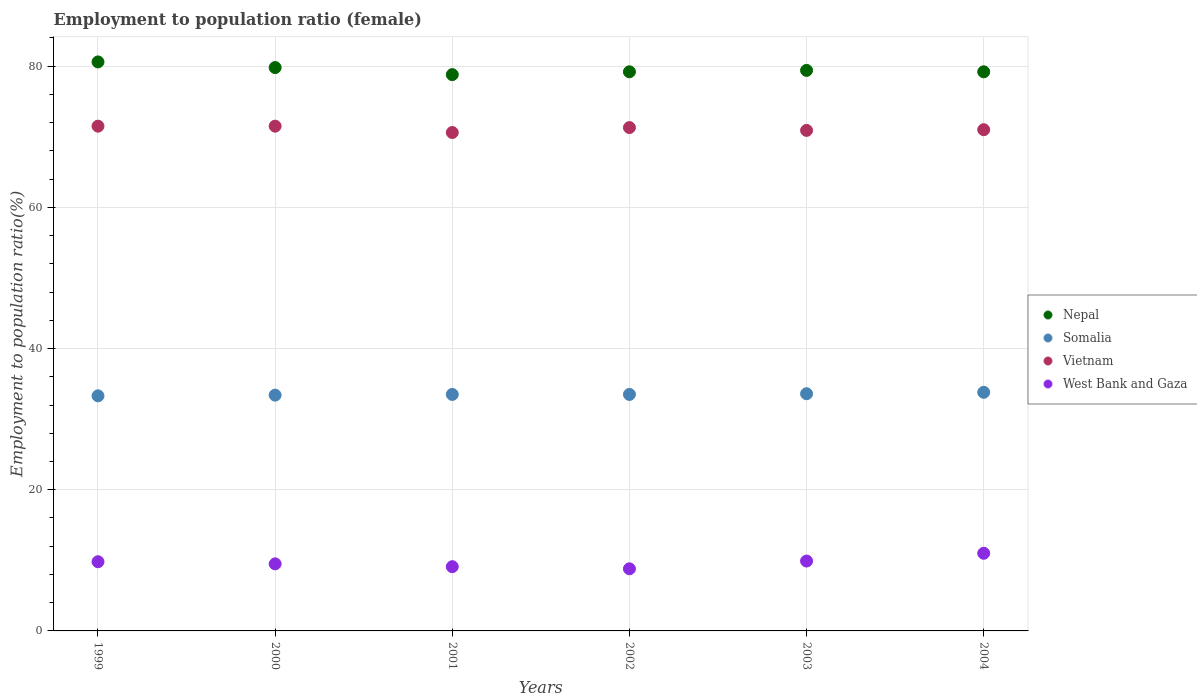How many different coloured dotlines are there?
Make the answer very short. 4. Is the number of dotlines equal to the number of legend labels?
Your answer should be very brief. Yes. What is the employment to population ratio in West Bank and Gaza in 2003?
Offer a terse response. 9.9. Across all years, what is the maximum employment to population ratio in Somalia?
Ensure brevity in your answer.  33.8. Across all years, what is the minimum employment to population ratio in West Bank and Gaza?
Provide a short and direct response. 8.8. In which year was the employment to population ratio in Vietnam maximum?
Provide a succinct answer. 1999. In which year was the employment to population ratio in Vietnam minimum?
Make the answer very short. 2001. What is the total employment to population ratio in Somalia in the graph?
Give a very brief answer. 201.1. What is the difference between the employment to population ratio in Nepal in 2000 and that in 2002?
Provide a succinct answer. 0.6. What is the difference between the employment to population ratio in Nepal in 2003 and the employment to population ratio in Vietnam in 2001?
Ensure brevity in your answer.  8.8. What is the average employment to population ratio in Somalia per year?
Your answer should be very brief. 33.52. In the year 2004, what is the difference between the employment to population ratio in Somalia and employment to population ratio in Nepal?
Your answer should be compact. -45.4. In how many years, is the employment to population ratio in Somalia greater than 4 %?
Provide a succinct answer. 6. What is the ratio of the employment to population ratio in West Bank and Gaza in 1999 to that in 2001?
Ensure brevity in your answer.  1.08. Is the employment to population ratio in Somalia in 2000 less than that in 2003?
Offer a very short reply. Yes. What is the difference between the highest and the second highest employment to population ratio in Vietnam?
Your response must be concise. 0. What is the difference between the highest and the lowest employment to population ratio in West Bank and Gaza?
Offer a very short reply. 2.2. Is the sum of the employment to population ratio in Nepal in 1999 and 2001 greater than the maximum employment to population ratio in West Bank and Gaza across all years?
Provide a short and direct response. Yes. Is it the case that in every year, the sum of the employment to population ratio in Vietnam and employment to population ratio in West Bank and Gaza  is greater than the employment to population ratio in Nepal?
Provide a short and direct response. Yes. Is the employment to population ratio in Vietnam strictly greater than the employment to population ratio in Somalia over the years?
Keep it short and to the point. Yes. Is the employment to population ratio in West Bank and Gaza strictly less than the employment to population ratio in Somalia over the years?
Keep it short and to the point. Yes. How many dotlines are there?
Provide a succinct answer. 4. How many years are there in the graph?
Your response must be concise. 6. Does the graph contain grids?
Offer a terse response. Yes. Where does the legend appear in the graph?
Provide a short and direct response. Center right. How many legend labels are there?
Make the answer very short. 4. What is the title of the graph?
Keep it short and to the point. Employment to population ratio (female). Does "Congo (Republic)" appear as one of the legend labels in the graph?
Provide a short and direct response. No. What is the label or title of the X-axis?
Make the answer very short. Years. What is the Employment to population ratio(%) in Nepal in 1999?
Make the answer very short. 80.6. What is the Employment to population ratio(%) in Somalia in 1999?
Your answer should be compact. 33.3. What is the Employment to population ratio(%) of Vietnam in 1999?
Your answer should be very brief. 71.5. What is the Employment to population ratio(%) of West Bank and Gaza in 1999?
Your answer should be very brief. 9.8. What is the Employment to population ratio(%) in Nepal in 2000?
Offer a very short reply. 79.8. What is the Employment to population ratio(%) of Somalia in 2000?
Provide a short and direct response. 33.4. What is the Employment to population ratio(%) in Vietnam in 2000?
Give a very brief answer. 71.5. What is the Employment to population ratio(%) in West Bank and Gaza in 2000?
Provide a short and direct response. 9.5. What is the Employment to population ratio(%) of Nepal in 2001?
Make the answer very short. 78.8. What is the Employment to population ratio(%) in Somalia in 2001?
Provide a short and direct response. 33.5. What is the Employment to population ratio(%) of Vietnam in 2001?
Your answer should be compact. 70.6. What is the Employment to population ratio(%) of West Bank and Gaza in 2001?
Your answer should be very brief. 9.1. What is the Employment to population ratio(%) in Nepal in 2002?
Your answer should be compact. 79.2. What is the Employment to population ratio(%) in Somalia in 2002?
Keep it short and to the point. 33.5. What is the Employment to population ratio(%) of Vietnam in 2002?
Ensure brevity in your answer.  71.3. What is the Employment to population ratio(%) of West Bank and Gaza in 2002?
Offer a terse response. 8.8. What is the Employment to population ratio(%) in Nepal in 2003?
Offer a terse response. 79.4. What is the Employment to population ratio(%) in Somalia in 2003?
Offer a very short reply. 33.6. What is the Employment to population ratio(%) in Vietnam in 2003?
Give a very brief answer. 70.9. What is the Employment to population ratio(%) in West Bank and Gaza in 2003?
Make the answer very short. 9.9. What is the Employment to population ratio(%) in Nepal in 2004?
Make the answer very short. 79.2. What is the Employment to population ratio(%) in Somalia in 2004?
Make the answer very short. 33.8. What is the Employment to population ratio(%) of West Bank and Gaza in 2004?
Your answer should be very brief. 11. Across all years, what is the maximum Employment to population ratio(%) of Nepal?
Give a very brief answer. 80.6. Across all years, what is the maximum Employment to population ratio(%) in Somalia?
Keep it short and to the point. 33.8. Across all years, what is the maximum Employment to population ratio(%) of Vietnam?
Provide a succinct answer. 71.5. Across all years, what is the minimum Employment to population ratio(%) of Nepal?
Ensure brevity in your answer.  78.8. Across all years, what is the minimum Employment to population ratio(%) of Somalia?
Your response must be concise. 33.3. Across all years, what is the minimum Employment to population ratio(%) of Vietnam?
Your answer should be compact. 70.6. Across all years, what is the minimum Employment to population ratio(%) of West Bank and Gaza?
Provide a succinct answer. 8.8. What is the total Employment to population ratio(%) in Nepal in the graph?
Your response must be concise. 477. What is the total Employment to population ratio(%) in Somalia in the graph?
Your answer should be very brief. 201.1. What is the total Employment to population ratio(%) of Vietnam in the graph?
Your answer should be very brief. 426.8. What is the total Employment to population ratio(%) of West Bank and Gaza in the graph?
Your answer should be very brief. 58.1. What is the difference between the Employment to population ratio(%) in Nepal in 1999 and that in 2000?
Give a very brief answer. 0.8. What is the difference between the Employment to population ratio(%) in Somalia in 1999 and that in 2000?
Offer a very short reply. -0.1. What is the difference between the Employment to population ratio(%) of West Bank and Gaza in 1999 and that in 2000?
Your response must be concise. 0.3. What is the difference between the Employment to population ratio(%) of Vietnam in 1999 and that in 2001?
Ensure brevity in your answer.  0.9. What is the difference between the Employment to population ratio(%) of West Bank and Gaza in 1999 and that in 2001?
Keep it short and to the point. 0.7. What is the difference between the Employment to population ratio(%) in Somalia in 1999 and that in 2002?
Make the answer very short. -0.2. What is the difference between the Employment to population ratio(%) in Vietnam in 1999 and that in 2002?
Offer a terse response. 0.2. What is the difference between the Employment to population ratio(%) of Nepal in 1999 and that in 2003?
Offer a very short reply. 1.2. What is the difference between the Employment to population ratio(%) in Vietnam in 1999 and that in 2004?
Offer a very short reply. 0.5. What is the difference between the Employment to population ratio(%) in West Bank and Gaza in 1999 and that in 2004?
Make the answer very short. -1.2. What is the difference between the Employment to population ratio(%) of Nepal in 2000 and that in 2001?
Provide a succinct answer. 1. What is the difference between the Employment to population ratio(%) in Vietnam in 2000 and that in 2001?
Ensure brevity in your answer.  0.9. What is the difference between the Employment to population ratio(%) of West Bank and Gaza in 2000 and that in 2001?
Provide a succinct answer. 0.4. What is the difference between the Employment to population ratio(%) in Nepal in 2000 and that in 2002?
Your response must be concise. 0.6. What is the difference between the Employment to population ratio(%) in Somalia in 2000 and that in 2002?
Provide a short and direct response. -0.1. What is the difference between the Employment to population ratio(%) of Somalia in 2000 and that in 2003?
Ensure brevity in your answer.  -0.2. What is the difference between the Employment to population ratio(%) in Vietnam in 2000 and that in 2003?
Ensure brevity in your answer.  0.6. What is the difference between the Employment to population ratio(%) in West Bank and Gaza in 2000 and that in 2003?
Offer a terse response. -0.4. What is the difference between the Employment to population ratio(%) in Somalia in 2000 and that in 2004?
Ensure brevity in your answer.  -0.4. What is the difference between the Employment to population ratio(%) in Vietnam in 2000 and that in 2004?
Give a very brief answer. 0.5. What is the difference between the Employment to population ratio(%) of Nepal in 2001 and that in 2002?
Ensure brevity in your answer.  -0.4. What is the difference between the Employment to population ratio(%) in West Bank and Gaza in 2001 and that in 2002?
Give a very brief answer. 0.3. What is the difference between the Employment to population ratio(%) in Vietnam in 2001 and that in 2003?
Your answer should be compact. -0.3. What is the difference between the Employment to population ratio(%) of Nepal in 2001 and that in 2004?
Offer a very short reply. -0.4. What is the difference between the Employment to population ratio(%) of Vietnam in 2001 and that in 2004?
Offer a terse response. -0.4. What is the difference between the Employment to population ratio(%) of West Bank and Gaza in 2001 and that in 2004?
Ensure brevity in your answer.  -1.9. What is the difference between the Employment to population ratio(%) in Vietnam in 2002 and that in 2003?
Your response must be concise. 0.4. What is the difference between the Employment to population ratio(%) in West Bank and Gaza in 2002 and that in 2003?
Your answer should be very brief. -1.1. What is the difference between the Employment to population ratio(%) of Nepal in 2002 and that in 2004?
Provide a succinct answer. 0. What is the difference between the Employment to population ratio(%) of West Bank and Gaza in 2002 and that in 2004?
Keep it short and to the point. -2.2. What is the difference between the Employment to population ratio(%) in Nepal in 2003 and that in 2004?
Your response must be concise. 0.2. What is the difference between the Employment to population ratio(%) in Somalia in 2003 and that in 2004?
Offer a terse response. -0.2. What is the difference between the Employment to population ratio(%) in Nepal in 1999 and the Employment to population ratio(%) in Somalia in 2000?
Offer a very short reply. 47.2. What is the difference between the Employment to population ratio(%) of Nepal in 1999 and the Employment to population ratio(%) of Vietnam in 2000?
Give a very brief answer. 9.1. What is the difference between the Employment to population ratio(%) in Nepal in 1999 and the Employment to population ratio(%) in West Bank and Gaza in 2000?
Make the answer very short. 71.1. What is the difference between the Employment to population ratio(%) of Somalia in 1999 and the Employment to population ratio(%) of Vietnam in 2000?
Your answer should be very brief. -38.2. What is the difference between the Employment to population ratio(%) in Somalia in 1999 and the Employment to population ratio(%) in West Bank and Gaza in 2000?
Provide a succinct answer. 23.8. What is the difference between the Employment to population ratio(%) in Vietnam in 1999 and the Employment to population ratio(%) in West Bank and Gaza in 2000?
Provide a succinct answer. 62. What is the difference between the Employment to population ratio(%) of Nepal in 1999 and the Employment to population ratio(%) of Somalia in 2001?
Provide a succinct answer. 47.1. What is the difference between the Employment to population ratio(%) of Nepal in 1999 and the Employment to population ratio(%) of Vietnam in 2001?
Give a very brief answer. 10. What is the difference between the Employment to population ratio(%) in Nepal in 1999 and the Employment to population ratio(%) in West Bank and Gaza in 2001?
Your response must be concise. 71.5. What is the difference between the Employment to population ratio(%) of Somalia in 1999 and the Employment to population ratio(%) of Vietnam in 2001?
Give a very brief answer. -37.3. What is the difference between the Employment to population ratio(%) of Somalia in 1999 and the Employment to population ratio(%) of West Bank and Gaza in 2001?
Provide a succinct answer. 24.2. What is the difference between the Employment to population ratio(%) of Vietnam in 1999 and the Employment to population ratio(%) of West Bank and Gaza in 2001?
Make the answer very short. 62.4. What is the difference between the Employment to population ratio(%) of Nepal in 1999 and the Employment to population ratio(%) of Somalia in 2002?
Offer a very short reply. 47.1. What is the difference between the Employment to population ratio(%) of Nepal in 1999 and the Employment to population ratio(%) of Vietnam in 2002?
Give a very brief answer. 9.3. What is the difference between the Employment to population ratio(%) in Nepal in 1999 and the Employment to population ratio(%) in West Bank and Gaza in 2002?
Your response must be concise. 71.8. What is the difference between the Employment to population ratio(%) of Somalia in 1999 and the Employment to population ratio(%) of Vietnam in 2002?
Keep it short and to the point. -38. What is the difference between the Employment to population ratio(%) of Somalia in 1999 and the Employment to population ratio(%) of West Bank and Gaza in 2002?
Make the answer very short. 24.5. What is the difference between the Employment to population ratio(%) in Vietnam in 1999 and the Employment to population ratio(%) in West Bank and Gaza in 2002?
Offer a terse response. 62.7. What is the difference between the Employment to population ratio(%) of Nepal in 1999 and the Employment to population ratio(%) of Somalia in 2003?
Make the answer very short. 47. What is the difference between the Employment to population ratio(%) in Nepal in 1999 and the Employment to population ratio(%) in West Bank and Gaza in 2003?
Make the answer very short. 70.7. What is the difference between the Employment to population ratio(%) of Somalia in 1999 and the Employment to population ratio(%) of Vietnam in 2003?
Your response must be concise. -37.6. What is the difference between the Employment to population ratio(%) in Somalia in 1999 and the Employment to population ratio(%) in West Bank and Gaza in 2003?
Offer a terse response. 23.4. What is the difference between the Employment to population ratio(%) of Vietnam in 1999 and the Employment to population ratio(%) of West Bank and Gaza in 2003?
Ensure brevity in your answer.  61.6. What is the difference between the Employment to population ratio(%) in Nepal in 1999 and the Employment to population ratio(%) in Somalia in 2004?
Your answer should be compact. 46.8. What is the difference between the Employment to population ratio(%) of Nepal in 1999 and the Employment to population ratio(%) of Vietnam in 2004?
Keep it short and to the point. 9.6. What is the difference between the Employment to population ratio(%) in Nepal in 1999 and the Employment to population ratio(%) in West Bank and Gaza in 2004?
Offer a very short reply. 69.6. What is the difference between the Employment to population ratio(%) of Somalia in 1999 and the Employment to population ratio(%) of Vietnam in 2004?
Offer a terse response. -37.7. What is the difference between the Employment to population ratio(%) of Somalia in 1999 and the Employment to population ratio(%) of West Bank and Gaza in 2004?
Give a very brief answer. 22.3. What is the difference between the Employment to population ratio(%) in Vietnam in 1999 and the Employment to population ratio(%) in West Bank and Gaza in 2004?
Keep it short and to the point. 60.5. What is the difference between the Employment to population ratio(%) of Nepal in 2000 and the Employment to population ratio(%) of Somalia in 2001?
Give a very brief answer. 46.3. What is the difference between the Employment to population ratio(%) of Nepal in 2000 and the Employment to population ratio(%) of West Bank and Gaza in 2001?
Provide a succinct answer. 70.7. What is the difference between the Employment to population ratio(%) in Somalia in 2000 and the Employment to population ratio(%) in Vietnam in 2001?
Ensure brevity in your answer.  -37.2. What is the difference between the Employment to population ratio(%) in Somalia in 2000 and the Employment to population ratio(%) in West Bank and Gaza in 2001?
Provide a short and direct response. 24.3. What is the difference between the Employment to population ratio(%) in Vietnam in 2000 and the Employment to population ratio(%) in West Bank and Gaza in 2001?
Offer a very short reply. 62.4. What is the difference between the Employment to population ratio(%) of Nepal in 2000 and the Employment to population ratio(%) of Somalia in 2002?
Offer a very short reply. 46.3. What is the difference between the Employment to population ratio(%) of Nepal in 2000 and the Employment to population ratio(%) of Vietnam in 2002?
Offer a terse response. 8.5. What is the difference between the Employment to population ratio(%) in Nepal in 2000 and the Employment to population ratio(%) in West Bank and Gaza in 2002?
Provide a short and direct response. 71. What is the difference between the Employment to population ratio(%) of Somalia in 2000 and the Employment to population ratio(%) of Vietnam in 2002?
Provide a succinct answer. -37.9. What is the difference between the Employment to population ratio(%) of Somalia in 2000 and the Employment to population ratio(%) of West Bank and Gaza in 2002?
Make the answer very short. 24.6. What is the difference between the Employment to population ratio(%) of Vietnam in 2000 and the Employment to population ratio(%) of West Bank and Gaza in 2002?
Offer a terse response. 62.7. What is the difference between the Employment to population ratio(%) of Nepal in 2000 and the Employment to population ratio(%) of Somalia in 2003?
Keep it short and to the point. 46.2. What is the difference between the Employment to population ratio(%) of Nepal in 2000 and the Employment to population ratio(%) of West Bank and Gaza in 2003?
Your answer should be compact. 69.9. What is the difference between the Employment to population ratio(%) of Somalia in 2000 and the Employment to population ratio(%) of Vietnam in 2003?
Give a very brief answer. -37.5. What is the difference between the Employment to population ratio(%) in Vietnam in 2000 and the Employment to population ratio(%) in West Bank and Gaza in 2003?
Your response must be concise. 61.6. What is the difference between the Employment to population ratio(%) in Nepal in 2000 and the Employment to population ratio(%) in Somalia in 2004?
Offer a terse response. 46. What is the difference between the Employment to population ratio(%) in Nepal in 2000 and the Employment to population ratio(%) in Vietnam in 2004?
Provide a short and direct response. 8.8. What is the difference between the Employment to population ratio(%) of Nepal in 2000 and the Employment to population ratio(%) of West Bank and Gaza in 2004?
Make the answer very short. 68.8. What is the difference between the Employment to population ratio(%) of Somalia in 2000 and the Employment to population ratio(%) of Vietnam in 2004?
Offer a terse response. -37.6. What is the difference between the Employment to population ratio(%) of Somalia in 2000 and the Employment to population ratio(%) of West Bank and Gaza in 2004?
Keep it short and to the point. 22.4. What is the difference between the Employment to population ratio(%) in Vietnam in 2000 and the Employment to population ratio(%) in West Bank and Gaza in 2004?
Provide a succinct answer. 60.5. What is the difference between the Employment to population ratio(%) of Nepal in 2001 and the Employment to population ratio(%) of Somalia in 2002?
Your answer should be compact. 45.3. What is the difference between the Employment to population ratio(%) in Somalia in 2001 and the Employment to population ratio(%) in Vietnam in 2002?
Ensure brevity in your answer.  -37.8. What is the difference between the Employment to population ratio(%) of Somalia in 2001 and the Employment to population ratio(%) of West Bank and Gaza in 2002?
Your response must be concise. 24.7. What is the difference between the Employment to population ratio(%) of Vietnam in 2001 and the Employment to population ratio(%) of West Bank and Gaza in 2002?
Offer a very short reply. 61.8. What is the difference between the Employment to population ratio(%) of Nepal in 2001 and the Employment to population ratio(%) of Somalia in 2003?
Make the answer very short. 45.2. What is the difference between the Employment to population ratio(%) of Nepal in 2001 and the Employment to population ratio(%) of Vietnam in 2003?
Your answer should be compact. 7.9. What is the difference between the Employment to population ratio(%) of Nepal in 2001 and the Employment to population ratio(%) of West Bank and Gaza in 2003?
Make the answer very short. 68.9. What is the difference between the Employment to population ratio(%) of Somalia in 2001 and the Employment to population ratio(%) of Vietnam in 2003?
Ensure brevity in your answer.  -37.4. What is the difference between the Employment to population ratio(%) in Somalia in 2001 and the Employment to population ratio(%) in West Bank and Gaza in 2003?
Your answer should be compact. 23.6. What is the difference between the Employment to population ratio(%) of Vietnam in 2001 and the Employment to population ratio(%) of West Bank and Gaza in 2003?
Offer a terse response. 60.7. What is the difference between the Employment to population ratio(%) of Nepal in 2001 and the Employment to population ratio(%) of Somalia in 2004?
Your answer should be compact. 45. What is the difference between the Employment to population ratio(%) of Nepal in 2001 and the Employment to population ratio(%) of Vietnam in 2004?
Your answer should be compact. 7.8. What is the difference between the Employment to population ratio(%) in Nepal in 2001 and the Employment to population ratio(%) in West Bank and Gaza in 2004?
Make the answer very short. 67.8. What is the difference between the Employment to population ratio(%) in Somalia in 2001 and the Employment to population ratio(%) in Vietnam in 2004?
Your response must be concise. -37.5. What is the difference between the Employment to population ratio(%) of Somalia in 2001 and the Employment to population ratio(%) of West Bank and Gaza in 2004?
Your answer should be very brief. 22.5. What is the difference between the Employment to population ratio(%) of Vietnam in 2001 and the Employment to population ratio(%) of West Bank and Gaza in 2004?
Keep it short and to the point. 59.6. What is the difference between the Employment to population ratio(%) of Nepal in 2002 and the Employment to population ratio(%) of Somalia in 2003?
Provide a short and direct response. 45.6. What is the difference between the Employment to population ratio(%) of Nepal in 2002 and the Employment to population ratio(%) of Vietnam in 2003?
Give a very brief answer. 8.3. What is the difference between the Employment to population ratio(%) in Nepal in 2002 and the Employment to population ratio(%) in West Bank and Gaza in 2003?
Offer a terse response. 69.3. What is the difference between the Employment to population ratio(%) of Somalia in 2002 and the Employment to population ratio(%) of Vietnam in 2003?
Give a very brief answer. -37.4. What is the difference between the Employment to population ratio(%) in Somalia in 2002 and the Employment to population ratio(%) in West Bank and Gaza in 2003?
Provide a short and direct response. 23.6. What is the difference between the Employment to population ratio(%) of Vietnam in 2002 and the Employment to population ratio(%) of West Bank and Gaza in 2003?
Provide a succinct answer. 61.4. What is the difference between the Employment to population ratio(%) of Nepal in 2002 and the Employment to population ratio(%) of Somalia in 2004?
Your answer should be very brief. 45.4. What is the difference between the Employment to population ratio(%) in Nepal in 2002 and the Employment to population ratio(%) in Vietnam in 2004?
Give a very brief answer. 8.2. What is the difference between the Employment to population ratio(%) in Nepal in 2002 and the Employment to population ratio(%) in West Bank and Gaza in 2004?
Give a very brief answer. 68.2. What is the difference between the Employment to population ratio(%) in Somalia in 2002 and the Employment to population ratio(%) in Vietnam in 2004?
Your response must be concise. -37.5. What is the difference between the Employment to population ratio(%) in Vietnam in 2002 and the Employment to population ratio(%) in West Bank and Gaza in 2004?
Your answer should be very brief. 60.3. What is the difference between the Employment to population ratio(%) in Nepal in 2003 and the Employment to population ratio(%) in Somalia in 2004?
Your answer should be very brief. 45.6. What is the difference between the Employment to population ratio(%) of Nepal in 2003 and the Employment to population ratio(%) of West Bank and Gaza in 2004?
Your answer should be compact. 68.4. What is the difference between the Employment to population ratio(%) of Somalia in 2003 and the Employment to population ratio(%) of Vietnam in 2004?
Offer a very short reply. -37.4. What is the difference between the Employment to population ratio(%) of Somalia in 2003 and the Employment to population ratio(%) of West Bank and Gaza in 2004?
Your answer should be compact. 22.6. What is the difference between the Employment to population ratio(%) in Vietnam in 2003 and the Employment to population ratio(%) in West Bank and Gaza in 2004?
Offer a terse response. 59.9. What is the average Employment to population ratio(%) in Nepal per year?
Your response must be concise. 79.5. What is the average Employment to population ratio(%) in Somalia per year?
Keep it short and to the point. 33.52. What is the average Employment to population ratio(%) in Vietnam per year?
Ensure brevity in your answer.  71.13. What is the average Employment to population ratio(%) in West Bank and Gaza per year?
Your answer should be very brief. 9.68. In the year 1999, what is the difference between the Employment to population ratio(%) in Nepal and Employment to population ratio(%) in Somalia?
Provide a short and direct response. 47.3. In the year 1999, what is the difference between the Employment to population ratio(%) of Nepal and Employment to population ratio(%) of West Bank and Gaza?
Your answer should be very brief. 70.8. In the year 1999, what is the difference between the Employment to population ratio(%) of Somalia and Employment to population ratio(%) of Vietnam?
Your answer should be compact. -38.2. In the year 1999, what is the difference between the Employment to population ratio(%) of Somalia and Employment to population ratio(%) of West Bank and Gaza?
Keep it short and to the point. 23.5. In the year 1999, what is the difference between the Employment to population ratio(%) in Vietnam and Employment to population ratio(%) in West Bank and Gaza?
Your response must be concise. 61.7. In the year 2000, what is the difference between the Employment to population ratio(%) of Nepal and Employment to population ratio(%) of Somalia?
Ensure brevity in your answer.  46.4. In the year 2000, what is the difference between the Employment to population ratio(%) of Nepal and Employment to population ratio(%) of West Bank and Gaza?
Keep it short and to the point. 70.3. In the year 2000, what is the difference between the Employment to population ratio(%) of Somalia and Employment to population ratio(%) of Vietnam?
Ensure brevity in your answer.  -38.1. In the year 2000, what is the difference between the Employment to population ratio(%) in Somalia and Employment to population ratio(%) in West Bank and Gaza?
Keep it short and to the point. 23.9. In the year 2001, what is the difference between the Employment to population ratio(%) in Nepal and Employment to population ratio(%) in Somalia?
Keep it short and to the point. 45.3. In the year 2001, what is the difference between the Employment to population ratio(%) in Nepal and Employment to population ratio(%) in Vietnam?
Provide a short and direct response. 8.2. In the year 2001, what is the difference between the Employment to population ratio(%) of Nepal and Employment to population ratio(%) of West Bank and Gaza?
Ensure brevity in your answer.  69.7. In the year 2001, what is the difference between the Employment to population ratio(%) in Somalia and Employment to population ratio(%) in Vietnam?
Keep it short and to the point. -37.1. In the year 2001, what is the difference between the Employment to population ratio(%) in Somalia and Employment to population ratio(%) in West Bank and Gaza?
Your answer should be compact. 24.4. In the year 2001, what is the difference between the Employment to population ratio(%) of Vietnam and Employment to population ratio(%) of West Bank and Gaza?
Your answer should be compact. 61.5. In the year 2002, what is the difference between the Employment to population ratio(%) in Nepal and Employment to population ratio(%) in Somalia?
Your answer should be compact. 45.7. In the year 2002, what is the difference between the Employment to population ratio(%) of Nepal and Employment to population ratio(%) of West Bank and Gaza?
Make the answer very short. 70.4. In the year 2002, what is the difference between the Employment to population ratio(%) in Somalia and Employment to population ratio(%) in Vietnam?
Provide a succinct answer. -37.8. In the year 2002, what is the difference between the Employment to population ratio(%) in Somalia and Employment to population ratio(%) in West Bank and Gaza?
Ensure brevity in your answer.  24.7. In the year 2002, what is the difference between the Employment to population ratio(%) of Vietnam and Employment to population ratio(%) of West Bank and Gaza?
Your answer should be very brief. 62.5. In the year 2003, what is the difference between the Employment to population ratio(%) in Nepal and Employment to population ratio(%) in Somalia?
Your response must be concise. 45.8. In the year 2003, what is the difference between the Employment to population ratio(%) in Nepal and Employment to population ratio(%) in West Bank and Gaza?
Offer a very short reply. 69.5. In the year 2003, what is the difference between the Employment to population ratio(%) in Somalia and Employment to population ratio(%) in Vietnam?
Provide a short and direct response. -37.3. In the year 2003, what is the difference between the Employment to population ratio(%) of Somalia and Employment to population ratio(%) of West Bank and Gaza?
Offer a very short reply. 23.7. In the year 2004, what is the difference between the Employment to population ratio(%) in Nepal and Employment to population ratio(%) in Somalia?
Your answer should be very brief. 45.4. In the year 2004, what is the difference between the Employment to population ratio(%) in Nepal and Employment to population ratio(%) in Vietnam?
Offer a very short reply. 8.2. In the year 2004, what is the difference between the Employment to population ratio(%) of Nepal and Employment to population ratio(%) of West Bank and Gaza?
Ensure brevity in your answer.  68.2. In the year 2004, what is the difference between the Employment to population ratio(%) of Somalia and Employment to population ratio(%) of Vietnam?
Your answer should be very brief. -37.2. In the year 2004, what is the difference between the Employment to population ratio(%) of Somalia and Employment to population ratio(%) of West Bank and Gaza?
Give a very brief answer. 22.8. What is the ratio of the Employment to population ratio(%) of West Bank and Gaza in 1999 to that in 2000?
Provide a succinct answer. 1.03. What is the ratio of the Employment to population ratio(%) in Nepal in 1999 to that in 2001?
Ensure brevity in your answer.  1.02. What is the ratio of the Employment to population ratio(%) of Somalia in 1999 to that in 2001?
Offer a terse response. 0.99. What is the ratio of the Employment to population ratio(%) in Vietnam in 1999 to that in 2001?
Ensure brevity in your answer.  1.01. What is the ratio of the Employment to population ratio(%) of West Bank and Gaza in 1999 to that in 2001?
Give a very brief answer. 1.08. What is the ratio of the Employment to population ratio(%) in Nepal in 1999 to that in 2002?
Provide a succinct answer. 1.02. What is the ratio of the Employment to population ratio(%) of Somalia in 1999 to that in 2002?
Offer a very short reply. 0.99. What is the ratio of the Employment to population ratio(%) in West Bank and Gaza in 1999 to that in 2002?
Offer a terse response. 1.11. What is the ratio of the Employment to population ratio(%) in Nepal in 1999 to that in 2003?
Your answer should be very brief. 1.02. What is the ratio of the Employment to population ratio(%) in Somalia in 1999 to that in 2003?
Ensure brevity in your answer.  0.99. What is the ratio of the Employment to population ratio(%) of Vietnam in 1999 to that in 2003?
Give a very brief answer. 1.01. What is the ratio of the Employment to population ratio(%) of West Bank and Gaza in 1999 to that in 2003?
Keep it short and to the point. 0.99. What is the ratio of the Employment to population ratio(%) in Nepal in 1999 to that in 2004?
Your response must be concise. 1.02. What is the ratio of the Employment to population ratio(%) in Somalia in 1999 to that in 2004?
Offer a very short reply. 0.99. What is the ratio of the Employment to population ratio(%) of Vietnam in 1999 to that in 2004?
Ensure brevity in your answer.  1.01. What is the ratio of the Employment to population ratio(%) in West Bank and Gaza in 1999 to that in 2004?
Your answer should be compact. 0.89. What is the ratio of the Employment to population ratio(%) of Nepal in 2000 to that in 2001?
Offer a very short reply. 1.01. What is the ratio of the Employment to population ratio(%) in Vietnam in 2000 to that in 2001?
Your answer should be compact. 1.01. What is the ratio of the Employment to population ratio(%) of West Bank and Gaza in 2000 to that in 2001?
Offer a terse response. 1.04. What is the ratio of the Employment to population ratio(%) of Nepal in 2000 to that in 2002?
Offer a terse response. 1.01. What is the ratio of the Employment to population ratio(%) of West Bank and Gaza in 2000 to that in 2002?
Provide a short and direct response. 1.08. What is the ratio of the Employment to population ratio(%) in Vietnam in 2000 to that in 2003?
Offer a terse response. 1.01. What is the ratio of the Employment to population ratio(%) in West Bank and Gaza in 2000 to that in 2003?
Offer a terse response. 0.96. What is the ratio of the Employment to population ratio(%) of Nepal in 2000 to that in 2004?
Provide a succinct answer. 1.01. What is the ratio of the Employment to population ratio(%) in Somalia in 2000 to that in 2004?
Provide a succinct answer. 0.99. What is the ratio of the Employment to population ratio(%) in West Bank and Gaza in 2000 to that in 2004?
Give a very brief answer. 0.86. What is the ratio of the Employment to population ratio(%) in Vietnam in 2001 to that in 2002?
Keep it short and to the point. 0.99. What is the ratio of the Employment to population ratio(%) in West Bank and Gaza in 2001 to that in 2002?
Provide a succinct answer. 1.03. What is the ratio of the Employment to population ratio(%) of Somalia in 2001 to that in 2003?
Offer a very short reply. 1. What is the ratio of the Employment to population ratio(%) of West Bank and Gaza in 2001 to that in 2003?
Ensure brevity in your answer.  0.92. What is the ratio of the Employment to population ratio(%) in Nepal in 2001 to that in 2004?
Provide a succinct answer. 0.99. What is the ratio of the Employment to population ratio(%) in Somalia in 2001 to that in 2004?
Your answer should be compact. 0.99. What is the ratio of the Employment to population ratio(%) of West Bank and Gaza in 2001 to that in 2004?
Provide a short and direct response. 0.83. What is the ratio of the Employment to population ratio(%) in Vietnam in 2002 to that in 2003?
Offer a very short reply. 1.01. What is the ratio of the Employment to population ratio(%) in West Bank and Gaza in 2002 to that in 2003?
Your answer should be very brief. 0.89. What is the ratio of the Employment to population ratio(%) in Nepal in 2002 to that in 2004?
Your response must be concise. 1. What is the ratio of the Employment to population ratio(%) in West Bank and Gaza in 2002 to that in 2004?
Make the answer very short. 0.8. What is the ratio of the Employment to population ratio(%) in Nepal in 2003 to that in 2004?
Offer a very short reply. 1. What is the ratio of the Employment to population ratio(%) in Vietnam in 2003 to that in 2004?
Your answer should be very brief. 1. What is the ratio of the Employment to population ratio(%) of West Bank and Gaza in 2003 to that in 2004?
Your answer should be very brief. 0.9. What is the difference between the highest and the second highest Employment to population ratio(%) of Nepal?
Make the answer very short. 0.8. What is the difference between the highest and the second highest Employment to population ratio(%) in Somalia?
Ensure brevity in your answer.  0.2. What is the difference between the highest and the second highest Employment to population ratio(%) in West Bank and Gaza?
Keep it short and to the point. 1.1. What is the difference between the highest and the lowest Employment to population ratio(%) of Somalia?
Offer a terse response. 0.5. What is the difference between the highest and the lowest Employment to population ratio(%) of Vietnam?
Your answer should be compact. 0.9. What is the difference between the highest and the lowest Employment to population ratio(%) of West Bank and Gaza?
Your answer should be very brief. 2.2. 